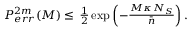Convert formula to latex. <formula><loc_0><loc_0><loc_500><loc_500>\begin{array} { r } { P _ { e r r } ^ { 2 m } ( M ) \leq \, \frac { 1 } { 2 } \exp \left ( - \frac { M \kappa \, N _ { S } } { \bar { n } } \right ) . } \end{array}</formula> 